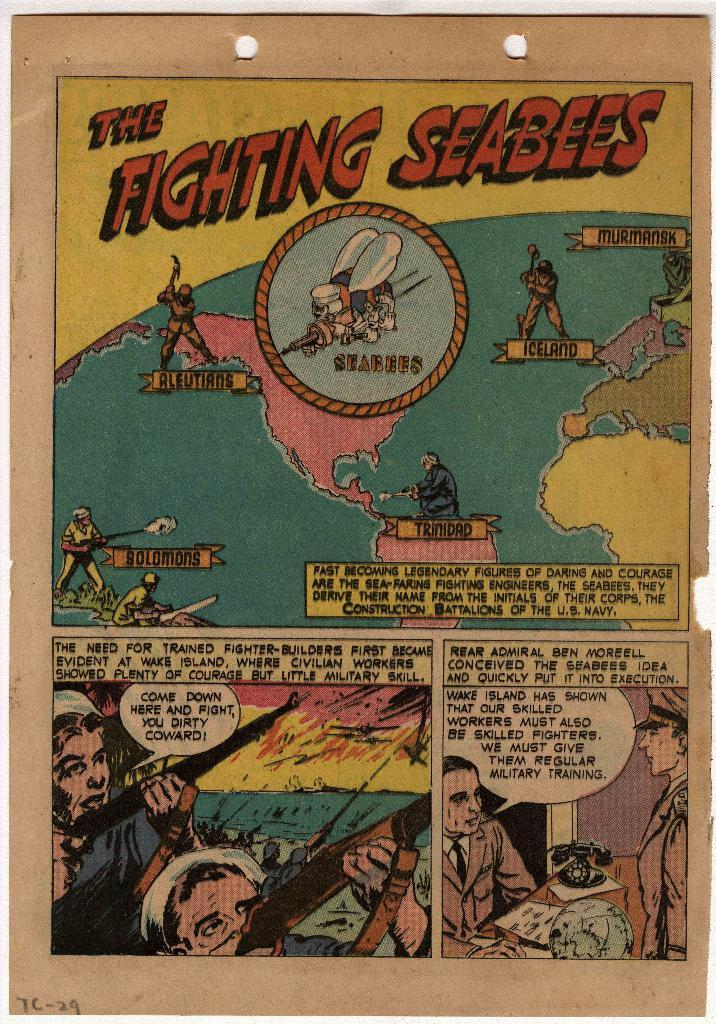<image>
Provide a brief description of the given image. an old comic book page titled the fighting seabees 